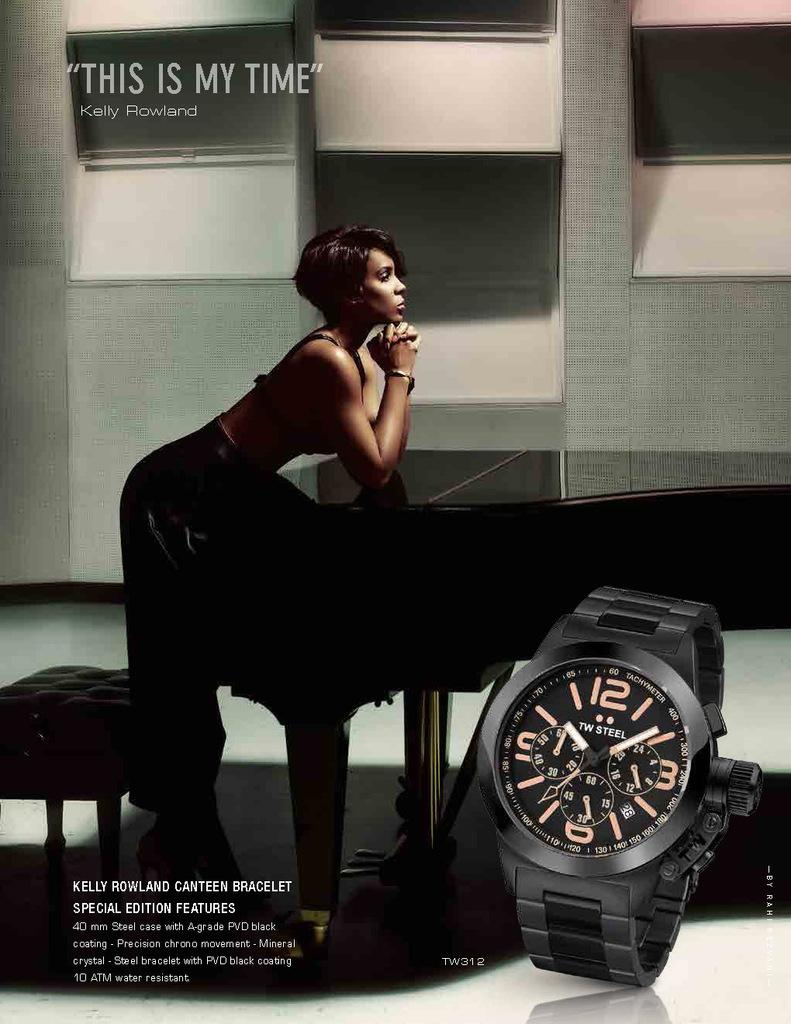<image>
Share a concise interpretation of the image provided. An advertisement shows Kelly Rowland and quotes he as saying this is my time. 